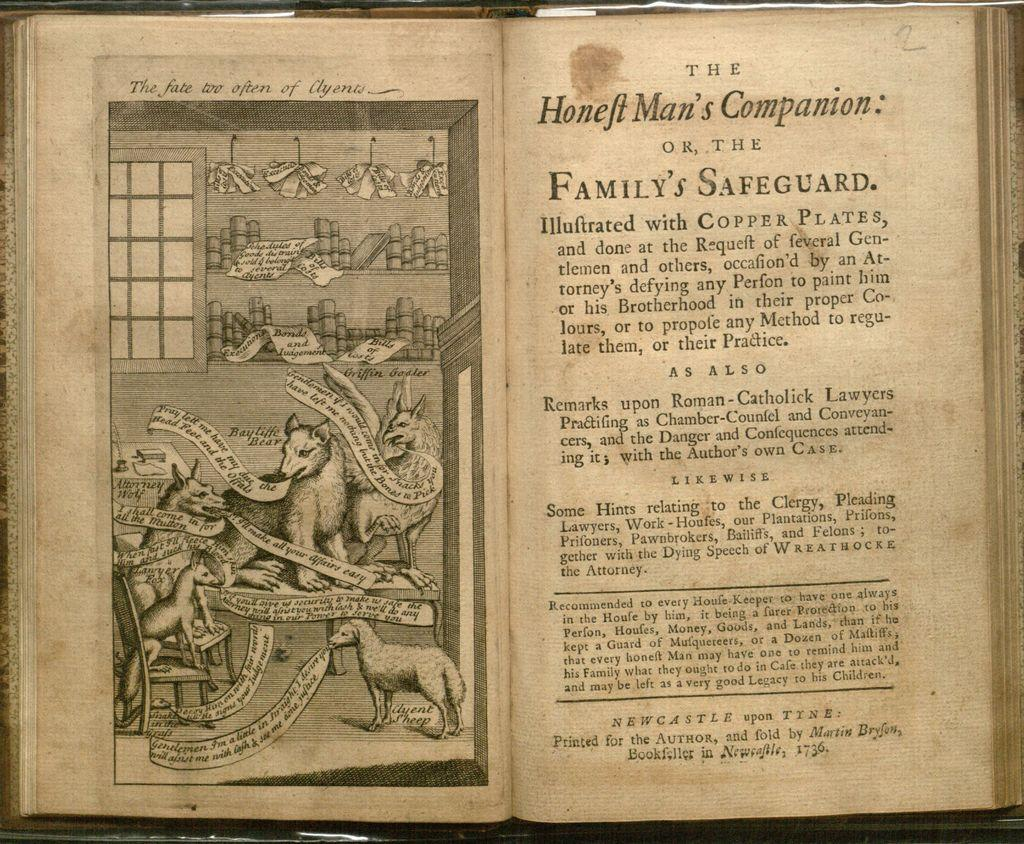<image>
Relay a brief, clear account of the picture shown. Black and white book opened to Honeft man's Companion 